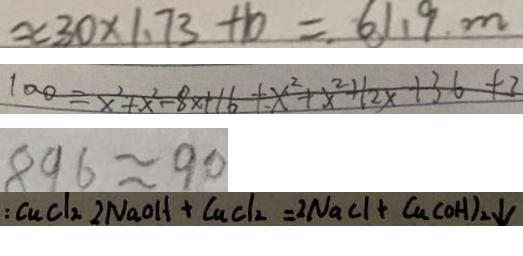<formula> <loc_0><loc_0><loc_500><loc_500>\approx 3 0 \times 1 . 7 3 + 1 0 = 6 1 . 9 m 
 1 0 0 = x ^ { 2 } + x ^ { 2 } - 8 x + 1 6 + x ^ { 2 } + x ^ { 2 } + 1 2 x + 3 6 + 3 
 8 9 6 \approx 9 0 
 : C u C l _ { 2 } 2 N a O H + C u C l _ { 2 } = 2 N a C l + C u ( O H ) _ { 2 } \downarrow</formula> 